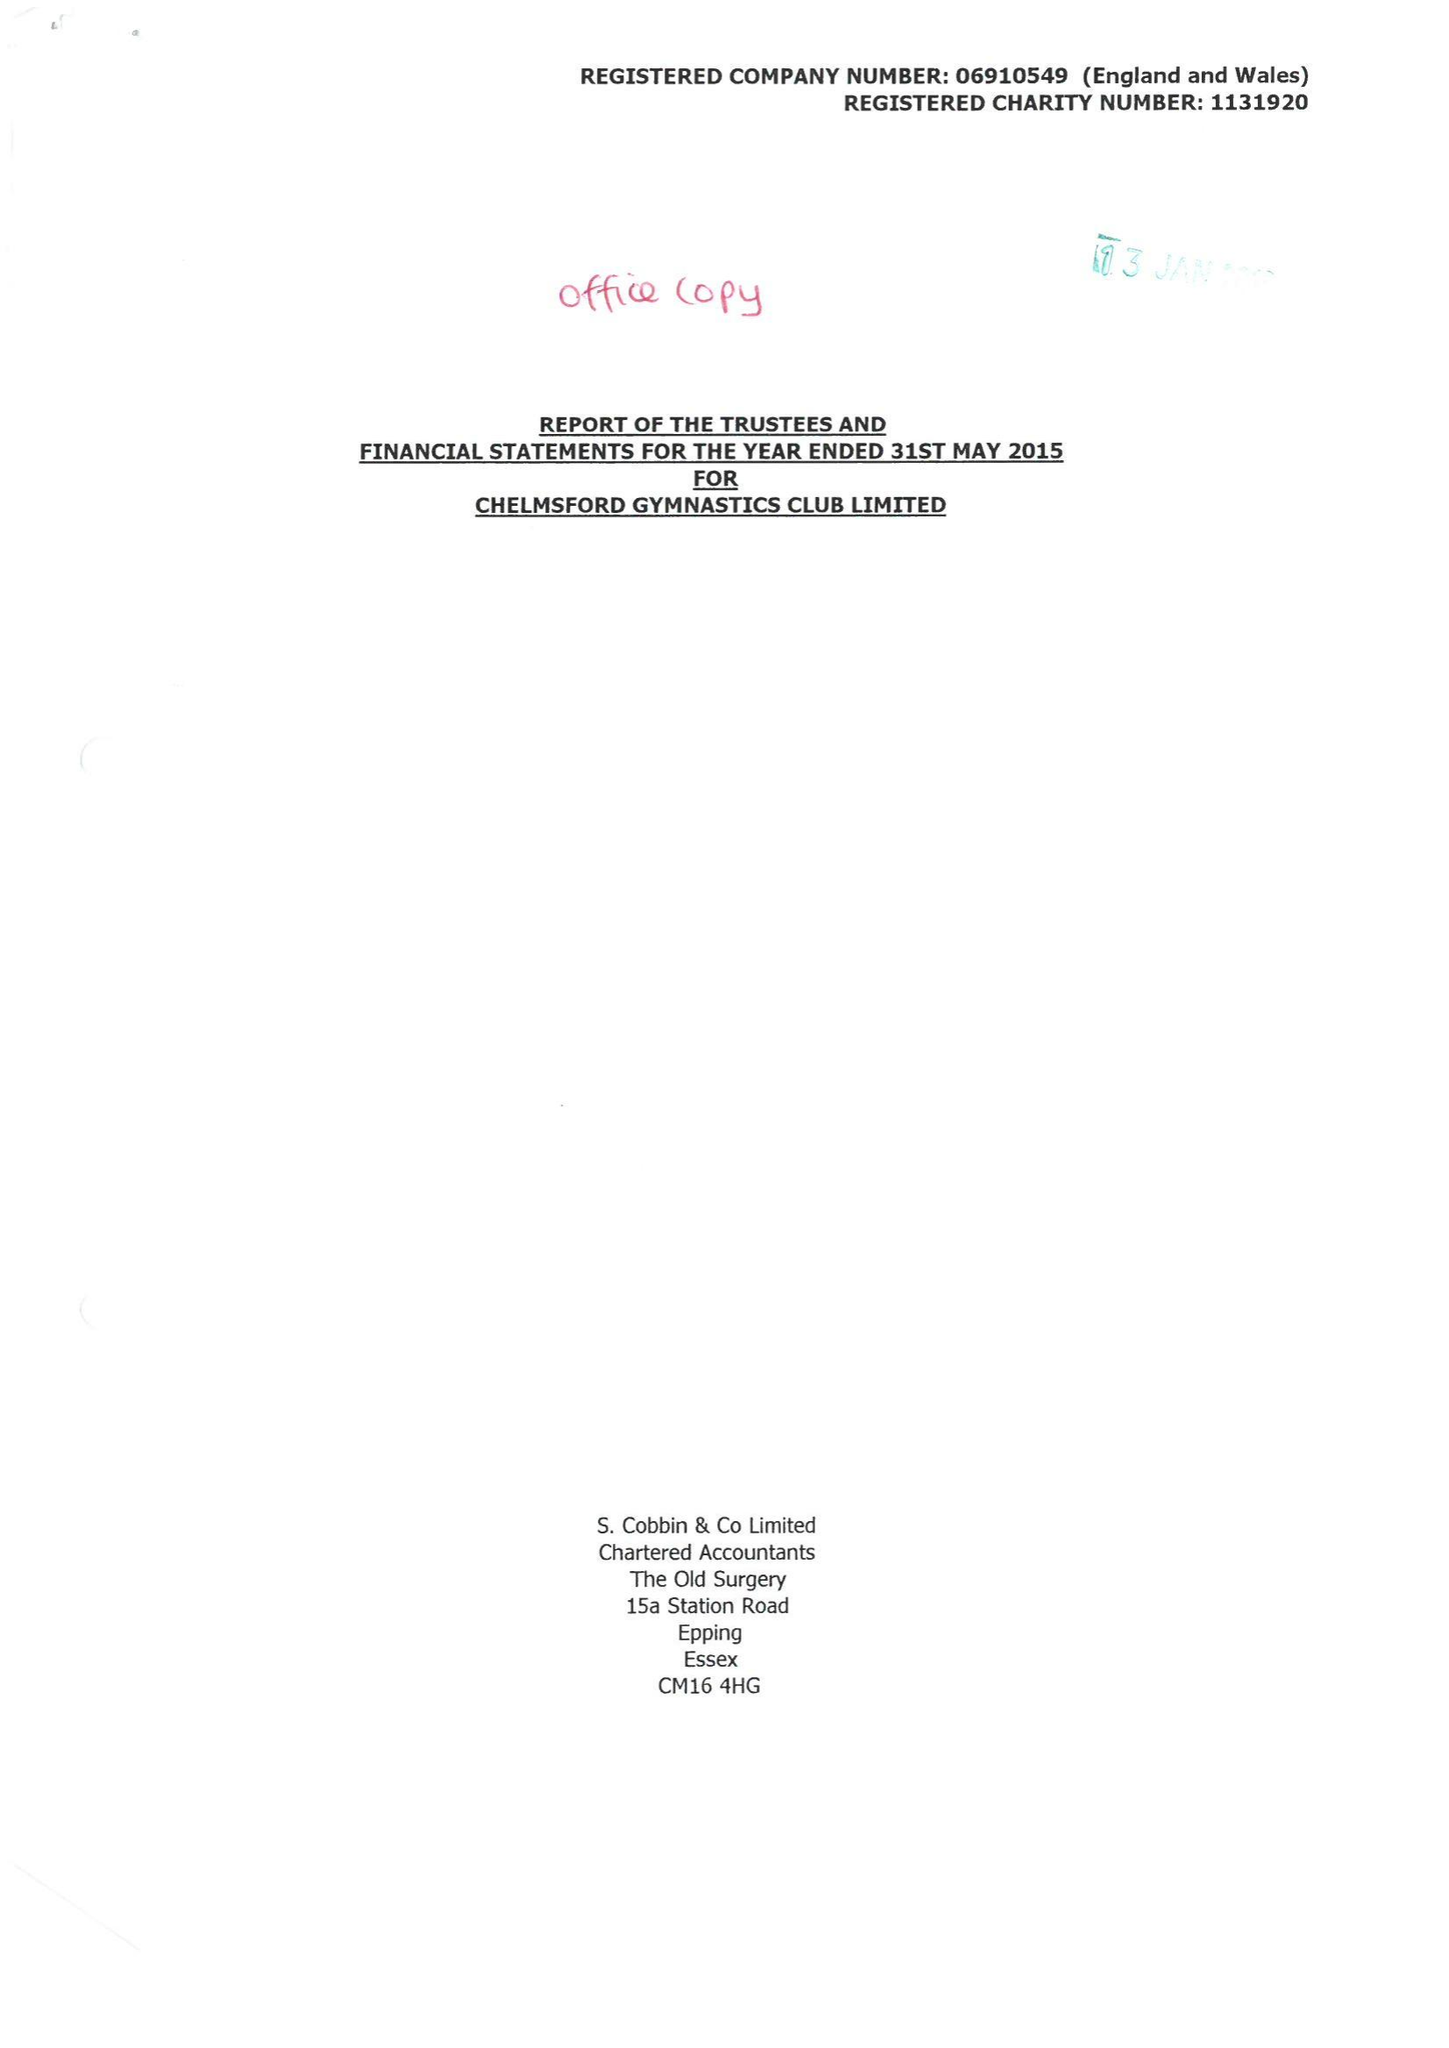What is the value for the address__postcode?
Answer the question using a single word or phrase. CM2 6BX 